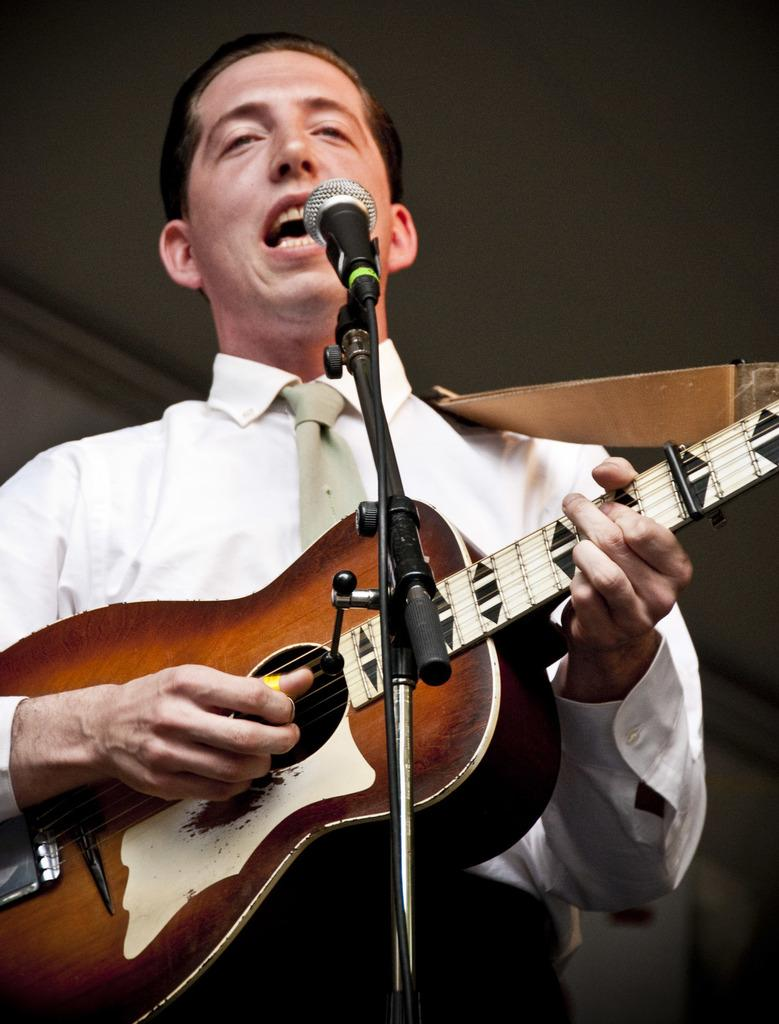What is the man in the image doing? The man is playing a guitar and singing a song. What object is the man using to amplify his voice? There is a microphone in the image. How is the microphone positioned in the image? There is a microphone stand in the image. What type of wrench is the man using to tune his guitar in the image? There is no wrench present in the image, and the man is not tuning his guitar. How many beds are visible in the image? There are no beds visible in the image; it features a man playing a guitar and singing. 